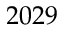Convert formula to latex. <formula><loc_0><loc_0><loc_500><loc_500>2 0 2 9</formula> 